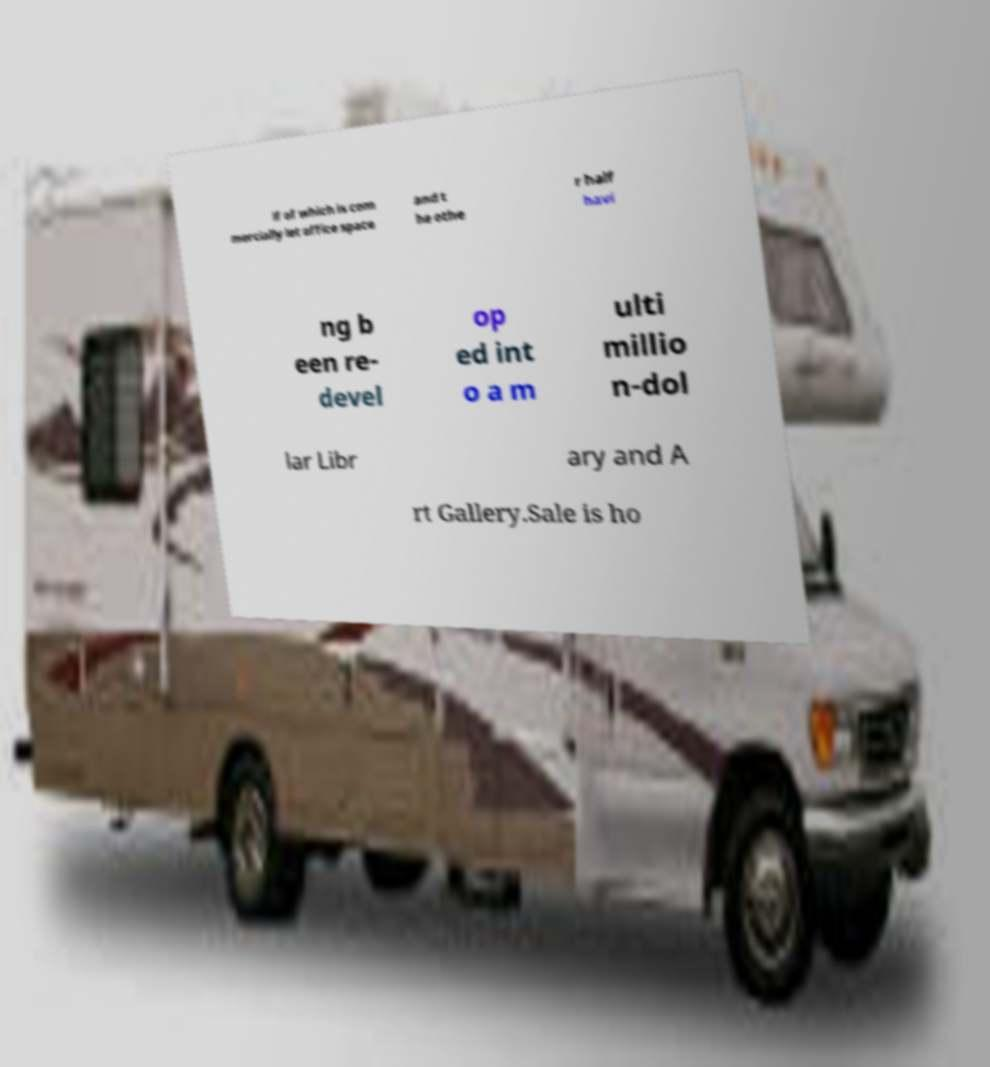Can you accurately transcribe the text from the provided image for me? lf of which is com mercially let office space and t he othe r half havi ng b een re- devel op ed int o a m ulti millio n-dol lar Libr ary and A rt Gallery.Sale is ho 